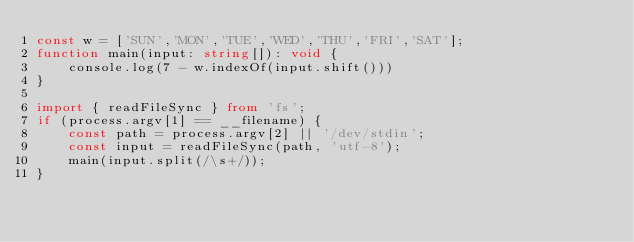Convert code to text. <code><loc_0><loc_0><loc_500><loc_500><_TypeScript_>const w = ['SUN','MON','TUE','WED','THU','FRI','SAT'];
function main(input: string[]): void {
    console.log(7 - w.indexOf(input.shift()))
}

import { readFileSync } from 'fs';
if (process.argv[1] == __filename) {
    const path = process.argv[2] || '/dev/stdin';
    const input = readFileSync(path, 'utf-8');
    main(input.split(/\s+/));
}</code> 